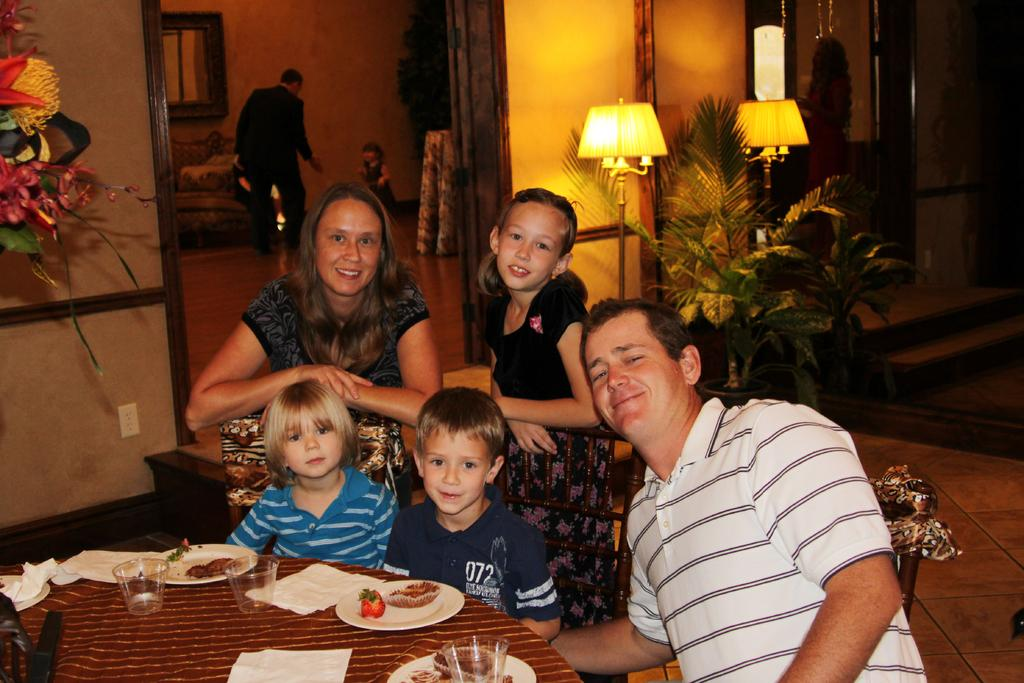How many people are sitting in front of the table in the image? There are three people sitting in front of the table in the image. What is on the table that the people are sitting in front of? The table has some eatables on it. How many people are standing behind the sitting people? There are two people standing behind the sitting people. Can you describe the people in the background of the image? There are two people in the background of the image. What type of ticket is being used by the people in the image? There is no ticket present in the image. Can you describe the carriage that the people are riding in the image? There is no carriage present in the image. 